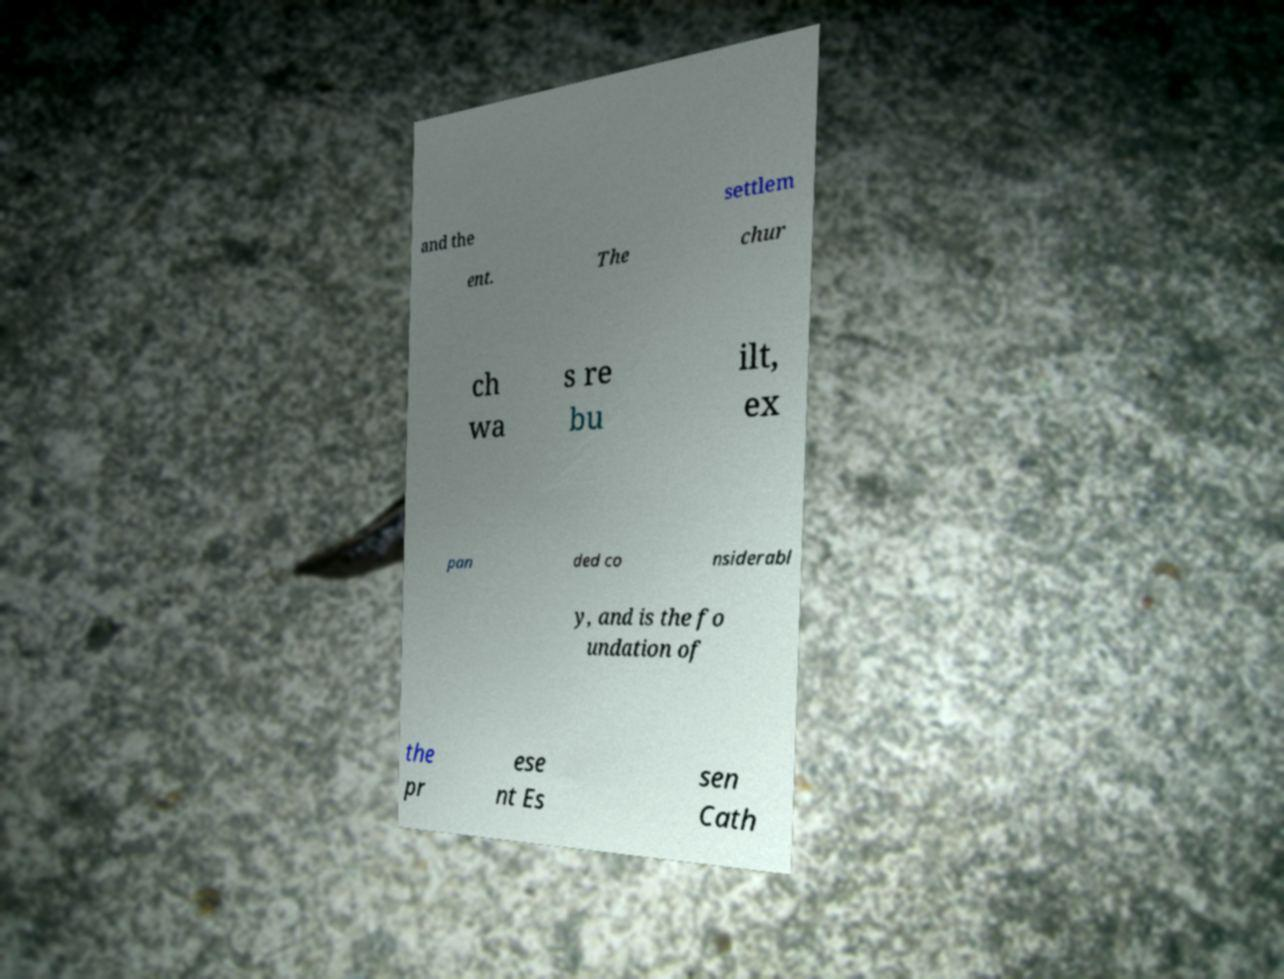Could you assist in decoding the text presented in this image and type it out clearly? and the settlem ent. The chur ch wa s re bu ilt, ex pan ded co nsiderabl y, and is the fo undation of the pr ese nt Es sen Cath 